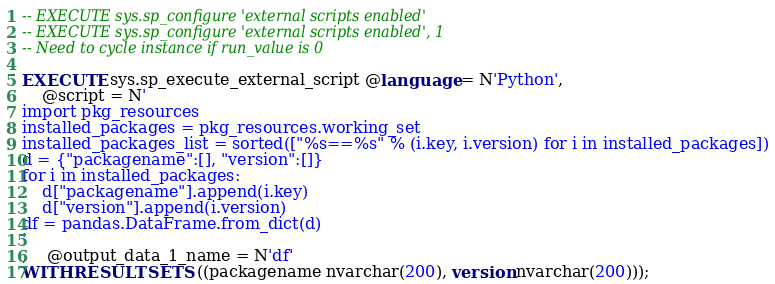Convert code to text. <code><loc_0><loc_0><loc_500><loc_500><_SQL_>-- EXECUTE sys.sp_configure 'external scripts enabled'
-- EXECUTE sys.sp_configure 'external scripts enabled', 1
-- Need to cycle instance if run_value is 0

EXECUTE sys.sp_execute_external_script @language = N'Python', 
	@script = N'
import pkg_resources
installed_packages = pkg_resources.working_set
installed_packages_list = sorted(["%s==%s" % (i.key, i.version) for i in installed_packages])
d = {"packagename":[], "version":[]}
for i in installed_packages:
    d["packagename"].append(i.key)
    d["version"].append(i.version)
df = pandas.DataFrame.from_dict(d)
'
,	@output_data_1_name = N'df'
WITH RESULT SETS ((packagename nvarchar(200), version nvarchar(200)));
</code> 